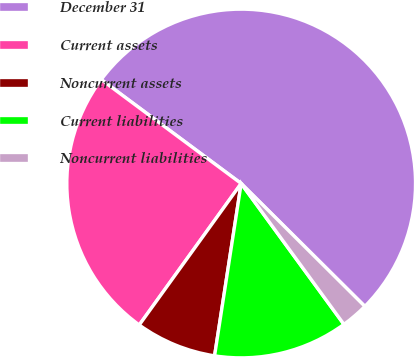Convert chart. <chart><loc_0><loc_0><loc_500><loc_500><pie_chart><fcel>December 31<fcel>Current assets<fcel>Noncurrent assets<fcel>Current liabilities<fcel>Noncurrent liabilities<nl><fcel>52.28%<fcel>25.23%<fcel>7.5%<fcel>12.47%<fcel>2.52%<nl></chart> 